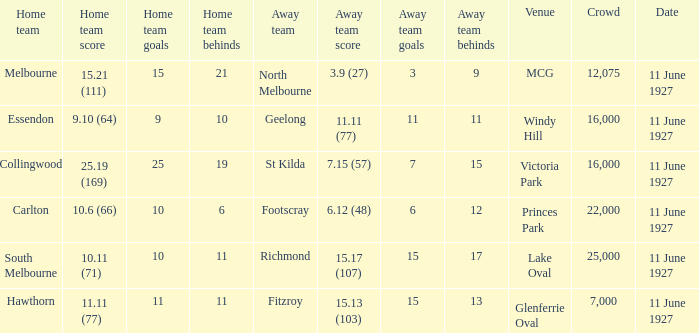How many people were present in a total of every crowd at the MCG venue? 12075.0. 